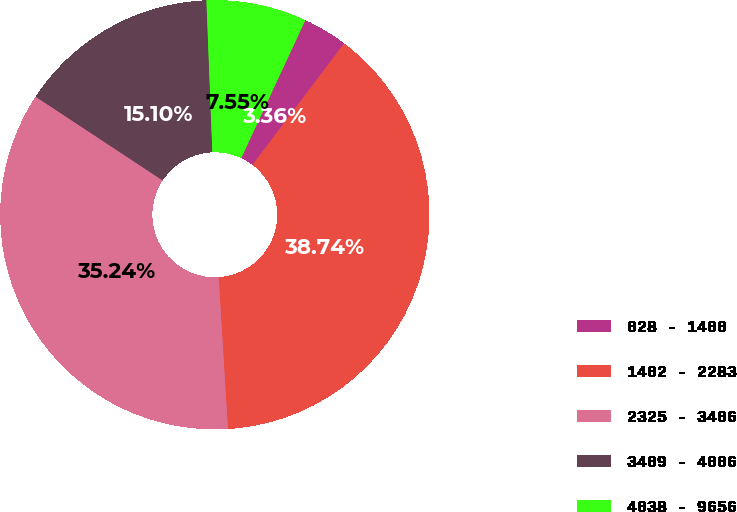Convert chart. <chart><loc_0><loc_0><loc_500><loc_500><pie_chart><fcel>028 - 1400<fcel>1402 - 2283<fcel>2325 - 3406<fcel>3409 - 4006<fcel>4038 - 9656<nl><fcel>3.36%<fcel>38.74%<fcel>35.24%<fcel>15.1%<fcel>7.55%<nl></chart> 